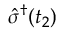<formula> <loc_0><loc_0><loc_500><loc_500>\hat { \sigma } ^ { \dagger } ( t _ { 2 } )</formula> 